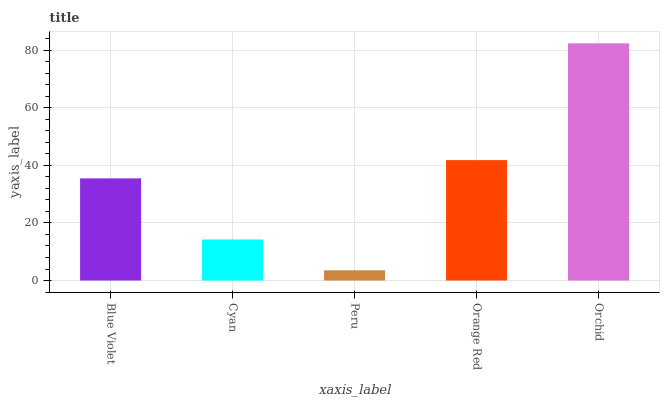Is Peru the minimum?
Answer yes or no. Yes. Is Orchid the maximum?
Answer yes or no. Yes. Is Cyan the minimum?
Answer yes or no. No. Is Cyan the maximum?
Answer yes or no. No. Is Blue Violet greater than Cyan?
Answer yes or no. Yes. Is Cyan less than Blue Violet?
Answer yes or no. Yes. Is Cyan greater than Blue Violet?
Answer yes or no. No. Is Blue Violet less than Cyan?
Answer yes or no. No. Is Blue Violet the high median?
Answer yes or no. Yes. Is Blue Violet the low median?
Answer yes or no. Yes. Is Orchid the high median?
Answer yes or no. No. Is Orange Red the low median?
Answer yes or no. No. 